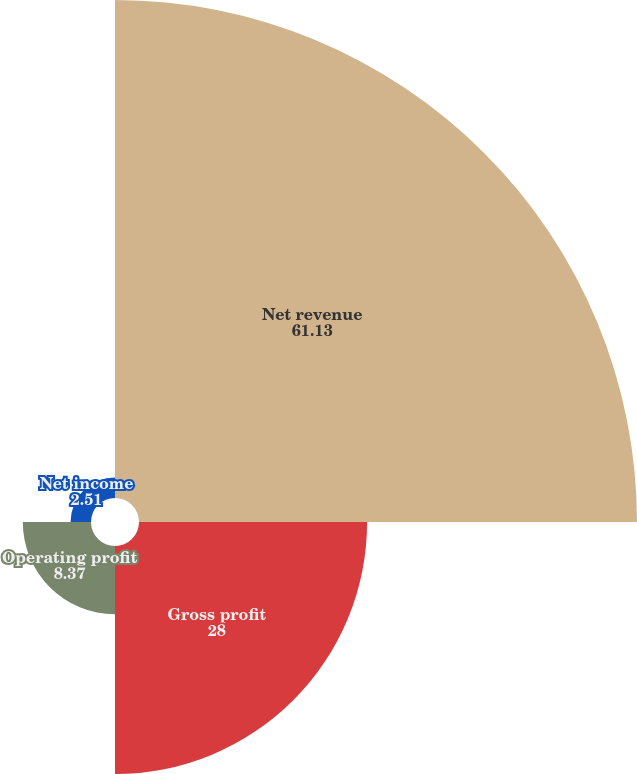<chart> <loc_0><loc_0><loc_500><loc_500><pie_chart><fcel>Net revenue<fcel>Gross profit<fcel>Operating profit<fcel>Net income<nl><fcel>61.13%<fcel>28.0%<fcel>8.37%<fcel>2.51%<nl></chart> 